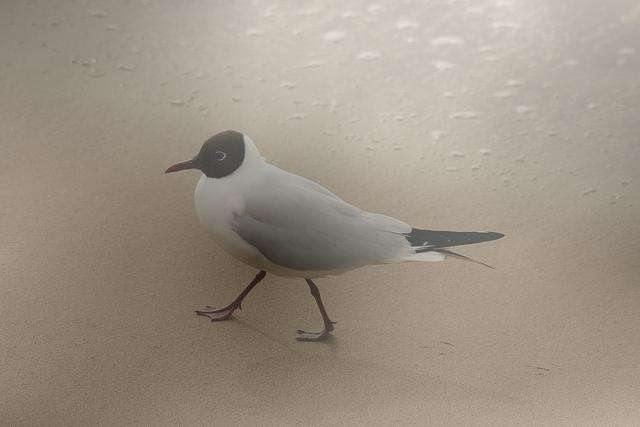Is the composition centered? Yes, the composition appears to be centered with the bird positioned in the middle of the frame, creating a balanced visual effect. 